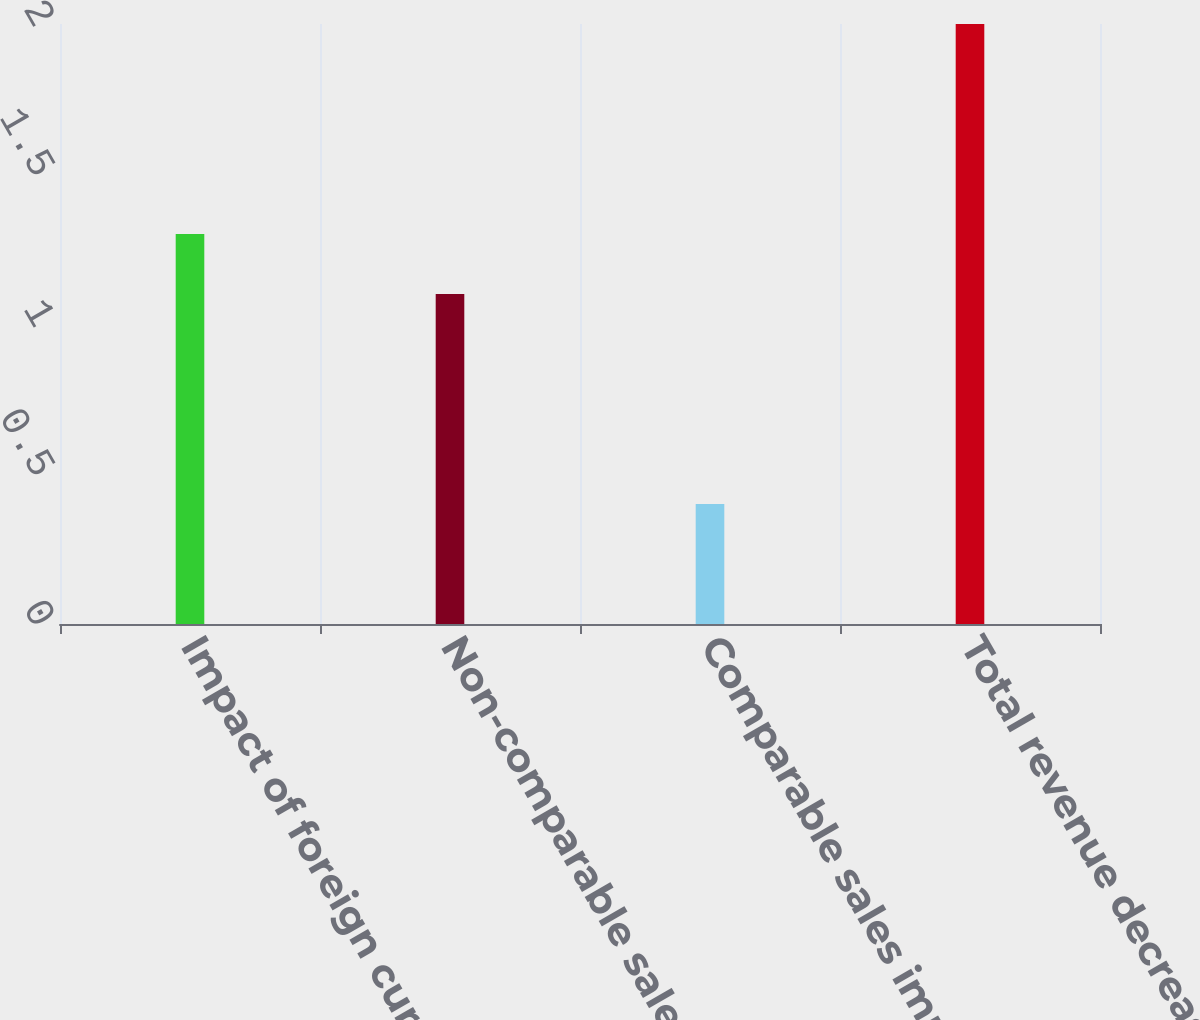<chart> <loc_0><loc_0><loc_500><loc_500><bar_chart><fcel>Impact of foreign currency<fcel>Non-comparable sales (1)<fcel>Comparable sales impact<fcel>Total revenue decrease<nl><fcel>1.3<fcel>1.1<fcel>0.4<fcel>2<nl></chart> 